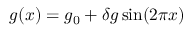Convert formula to latex. <formula><loc_0><loc_0><loc_500><loc_500>g ( x ) = g _ { 0 } + \delta g \sin ( 2 \pi x )</formula> 